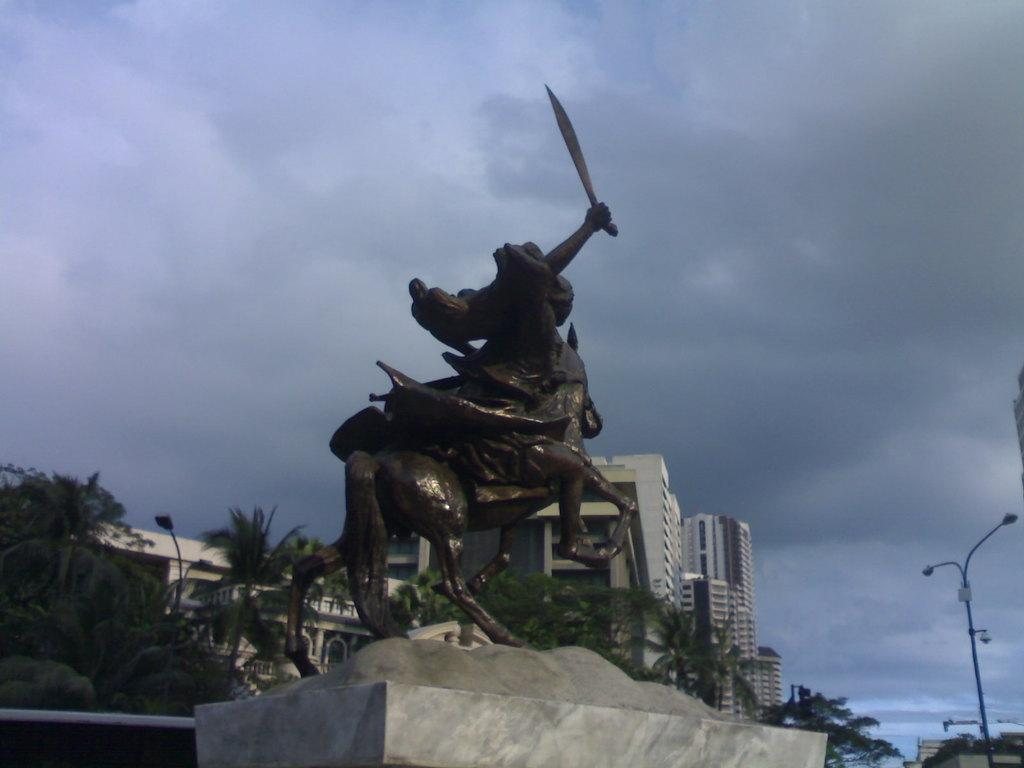What is the main subject in the center of the image? There is a statue in the center of the image. What can be seen in the background of the image? There are buildings, trees, and the sky visible in the background of the image. Are there any clouds in the sky? Yes, there are clouds in the background of the image. What is located on the right side of the image? There is a light pole on the right side of the image. How many balls are being juggled by the statue in the image? There are no balls present in the image, and the statue is not depicted as juggling anything. 